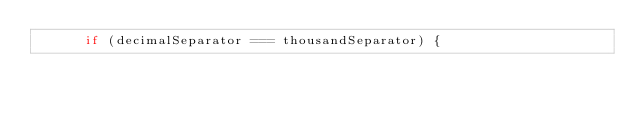Convert code to text. <code><loc_0><loc_0><loc_500><loc_500><_JavaScript_>      if (decimalSeparator === thousandSeparator) {</code> 